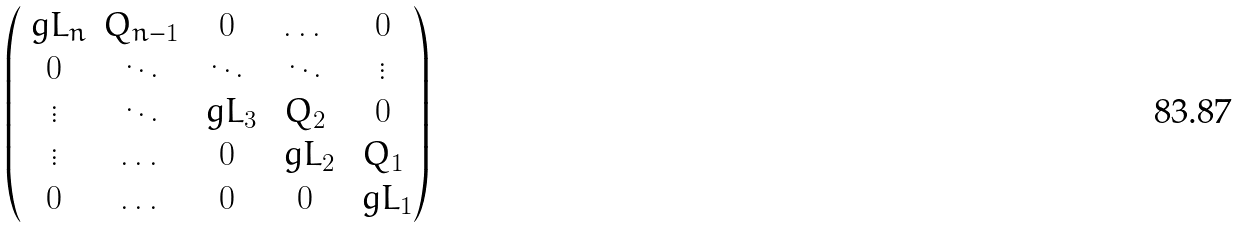Convert formula to latex. <formula><loc_0><loc_0><loc_500><loc_500>\begin{pmatrix} \ g L _ { n } & Q _ { n - 1 } & 0 & \dots & 0 \\ 0 & \ddots & \ddots & \ddots & \vdots \\ \vdots & \ddots & \ g L _ { 3 } & Q _ { 2 } & 0 \\ \vdots & \dots & 0 & \ g L _ { 2 } & Q _ { 1 } \\ 0 & \dots & 0 & 0 & \ g L _ { 1 } \end{pmatrix}</formula> 